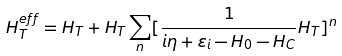<formula> <loc_0><loc_0><loc_500><loc_500>H _ { T } ^ { e f f } = H _ { T } + H _ { T } \sum _ { n } [ \frac { 1 } { i \eta + \varepsilon _ { i } - H _ { 0 } - H _ { C } } H _ { T } ] ^ { n }</formula> 